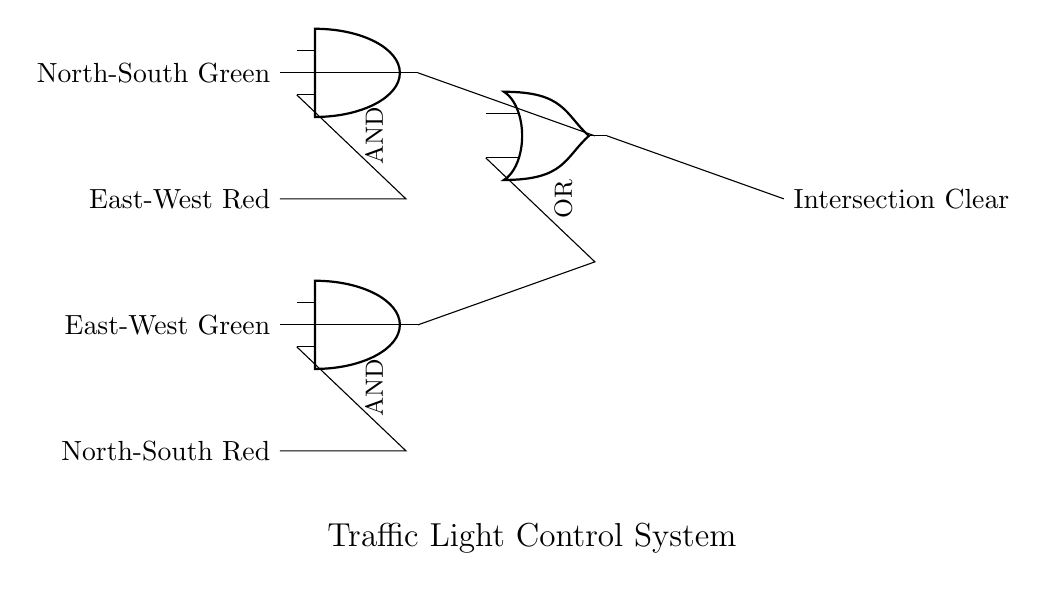What are the inputs for the first AND gate? The inputs for the first AND gate (North-South Green) come from the North-South Green signal and the East-West Red signal.
Answer: North-South Green, East-West Red What is the function of the OR gate? The OR gate combines the outputs of the two AND gates. It outputs an "Intersection Clear" signal when either of the AND gates yields a high signal, indicating that the intersection can be cleared for traffic.
Answer: Intersection Clear How many AND gates are there in this circuit? There are two AND gates present in this circuit, each responsible for managing the traffic signals for different directions.
Answer: 2 If both input conditions for the first AND gate are true, what will be the output? If the North-South Green signal is true and the East-West Red signal is true, the output of the first AND gate will also be true, indicating that North-South traffic can proceed.
Answer: True What connections feed into the second AND gate? The second AND gate receives inputs from the East-West Green signal and the North-South Red signal, which indicates that traffic from the East-West direction can proceed while the North-South direction is stopped.
Answer: East-West Green, North-South Red What needs to happen for the intersection to be clear? The intersection will be clear when at least one of the AND gates outputs a high signal, which is then read by the OR gate and results in the intersection clear signal being activated.
Answer: At least one AND gate outputs high 